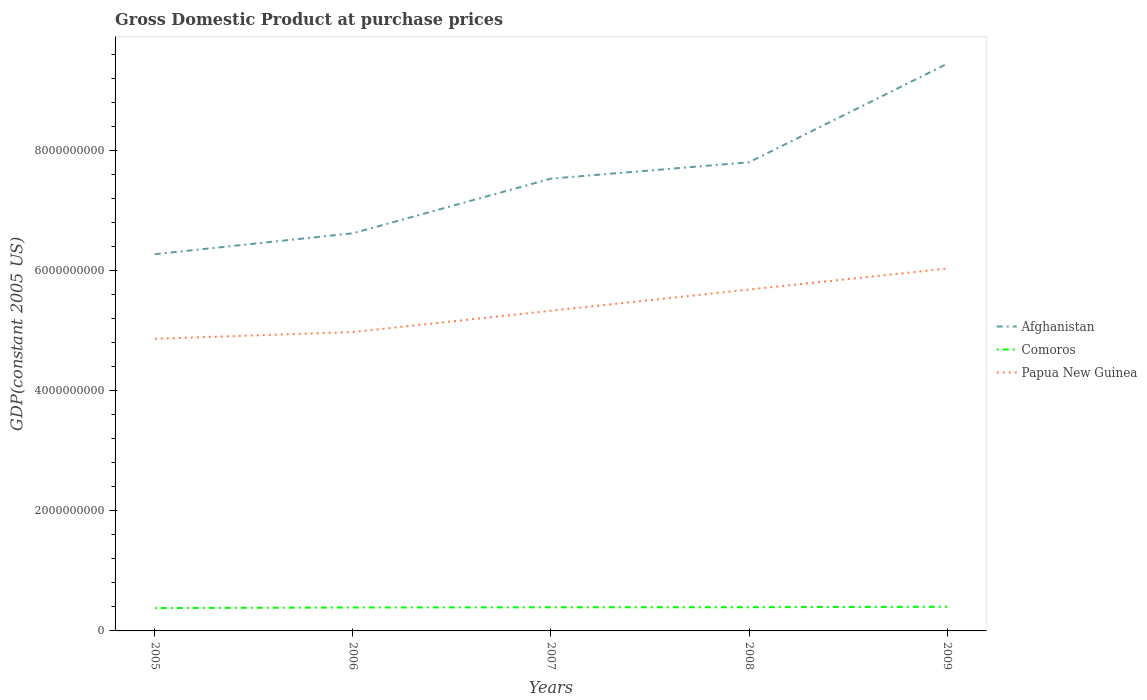Does the line corresponding to Comoros intersect with the line corresponding to Afghanistan?
Your answer should be compact. No. Across all years, what is the maximum GDP at purchase prices in Afghanistan?
Make the answer very short. 6.28e+09. In which year was the GDP at purchase prices in Papua New Guinea maximum?
Your response must be concise. 2005. What is the total GDP at purchase prices in Comoros in the graph?
Ensure brevity in your answer.  -3.12e+06. What is the difference between the highest and the second highest GDP at purchase prices in Papua New Guinea?
Your answer should be compact. 1.17e+09. Is the GDP at purchase prices in Comoros strictly greater than the GDP at purchase prices in Papua New Guinea over the years?
Your answer should be compact. Yes. How many lines are there?
Offer a terse response. 3. What is the difference between two consecutive major ticks on the Y-axis?
Ensure brevity in your answer.  2.00e+09. Does the graph contain any zero values?
Provide a succinct answer. No. What is the title of the graph?
Offer a terse response. Gross Domestic Product at purchase prices. What is the label or title of the Y-axis?
Offer a very short reply. GDP(constant 2005 US). What is the GDP(constant 2005 US) in Afghanistan in 2005?
Offer a terse response. 6.28e+09. What is the GDP(constant 2005 US) in Comoros in 2005?
Your response must be concise. 3.80e+08. What is the GDP(constant 2005 US) of Papua New Guinea in 2005?
Keep it short and to the point. 4.87e+09. What is the GDP(constant 2005 US) of Afghanistan in 2006?
Your response must be concise. 6.62e+09. What is the GDP(constant 2005 US) in Comoros in 2006?
Provide a short and direct response. 3.90e+08. What is the GDP(constant 2005 US) in Papua New Guinea in 2006?
Provide a succinct answer. 4.98e+09. What is the GDP(constant 2005 US) in Afghanistan in 2007?
Offer a very short reply. 7.53e+09. What is the GDP(constant 2005 US) in Comoros in 2007?
Provide a short and direct response. 3.94e+08. What is the GDP(constant 2005 US) of Papua New Guinea in 2007?
Offer a terse response. 5.33e+09. What is the GDP(constant 2005 US) in Afghanistan in 2008?
Keep it short and to the point. 7.81e+09. What is the GDP(constant 2005 US) in Comoros in 2008?
Your answer should be compact. 3.95e+08. What is the GDP(constant 2005 US) in Papua New Guinea in 2008?
Ensure brevity in your answer.  5.69e+09. What is the GDP(constant 2005 US) in Afghanistan in 2009?
Your response must be concise. 9.45e+09. What is the GDP(constant 2005 US) in Comoros in 2009?
Give a very brief answer. 4.03e+08. What is the GDP(constant 2005 US) of Papua New Guinea in 2009?
Keep it short and to the point. 6.04e+09. Across all years, what is the maximum GDP(constant 2005 US) of Afghanistan?
Make the answer very short. 9.45e+09. Across all years, what is the maximum GDP(constant 2005 US) in Comoros?
Your response must be concise. 4.03e+08. Across all years, what is the maximum GDP(constant 2005 US) in Papua New Guinea?
Keep it short and to the point. 6.04e+09. Across all years, what is the minimum GDP(constant 2005 US) of Afghanistan?
Your answer should be very brief. 6.28e+09. Across all years, what is the minimum GDP(constant 2005 US) of Comoros?
Provide a succinct answer. 3.80e+08. Across all years, what is the minimum GDP(constant 2005 US) of Papua New Guinea?
Offer a terse response. 4.87e+09. What is the total GDP(constant 2005 US) of Afghanistan in the graph?
Make the answer very short. 3.77e+1. What is the total GDP(constant 2005 US) of Comoros in the graph?
Make the answer very short. 1.96e+09. What is the total GDP(constant 2005 US) of Papua New Guinea in the graph?
Offer a terse response. 2.69e+1. What is the difference between the GDP(constant 2005 US) in Afghanistan in 2005 and that in 2006?
Keep it short and to the point. -3.49e+08. What is the difference between the GDP(constant 2005 US) of Comoros in 2005 and that in 2006?
Provide a short and direct response. -1.01e+07. What is the difference between the GDP(constant 2005 US) in Papua New Guinea in 2005 and that in 2006?
Offer a very short reply. -1.12e+08. What is the difference between the GDP(constant 2005 US) of Afghanistan in 2005 and that in 2007?
Make the answer very short. -1.26e+09. What is the difference between the GDP(constant 2005 US) in Comoros in 2005 and that in 2007?
Ensure brevity in your answer.  -1.32e+07. What is the difference between the GDP(constant 2005 US) in Papua New Guinea in 2005 and that in 2007?
Offer a terse response. -4.68e+08. What is the difference between the GDP(constant 2005 US) of Afghanistan in 2005 and that in 2008?
Make the answer very short. -1.53e+09. What is the difference between the GDP(constant 2005 US) of Comoros in 2005 and that in 2008?
Your answer should be very brief. -1.48e+07. What is the difference between the GDP(constant 2005 US) in Papua New Guinea in 2005 and that in 2008?
Make the answer very short. -8.20e+08. What is the difference between the GDP(constant 2005 US) of Afghanistan in 2005 and that in 2009?
Provide a short and direct response. -3.17e+09. What is the difference between the GDP(constant 2005 US) in Comoros in 2005 and that in 2009?
Ensure brevity in your answer.  -2.25e+07. What is the difference between the GDP(constant 2005 US) of Papua New Guinea in 2005 and that in 2009?
Your answer should be compact. -1.17e+09. What is the difference between the GDP(constant 2005 US) of Afghanistan in 2006 and that in 2007?
Ensure brevity in your answer.  -9.10e+08. What is the difference between the GDP(constant 2005 US) in Comoros in 2006 and that in 2007?
Provide a short and direct response. -3.12e+06. What is the difference between the GDP(constant 2005 US) in Papua New Guinea in 2006 and that in 2007?
Provide a succinct answer. -3.56e+08. What is the difference between the GDP(constant 2005 US) in Afghanistan in 2006 and that in 2008?
Provide a short and direct response. -1.18e+09. What is the difference between the GDP(constant 2005 US) in Comoros in 2006 and that in 2008?
Provide a short and direct response. -4.70e+06. What is the difference between the GDP(constant 2005 US) of Papua New Guinea in 2006 and that in 2008?
Offer a terse response. -7.09e+08. What is the difference between the GDP(constant 2005 US) of Afghanistan in 2006 and that in 2009?
Ensure brevity in your answer.  -2.82e+09. What is the difference between the GDP(constant 2005 US) of Comoros in 2006 and that in 2009?
Keep it short and to the point. -1.24e+07. What is the difference between the GDP(constant 2005 US) of Papua New Guinea in 2006 and that in 2009?
Provide a short and direct response. -1.06e+09. What is the difference between the GDP(constant 2005 US) in Afghanistan in 2007 and that in 2008?
Make the answer very short. -2.72e+08. What is the difference between the GDP(constant 2005 US) of Comoros in 2007 and that in 2008?
Your answer should be compact. -1.58e+06. What is the difference between the GDP(constant 2005 US) of Papua New Guinea in 2007 and that in 2008?
Make the answer very short. -3.53e+08. What is the difference between the GDP(constant 2005 US) in Afghanistan in 2007 and that in 2009?
Your answer should be very brief. -1.91e+09. What is the difference between the GDP(constant 2005 US) of Comoros in 2007 and that in 2009?
Your response must be concise. -9.28e+06. What is the difference between the GDP(constant 2005 US) in Papua New Guinea in 2007 and that in 2009?
Make the answer very short. -7.02e+08. What is the difference between the GDP(constant 2005 US) in Afghanistan in 2008 and that in 2009?
Your answer should be compact. -1.64e+09. What is the difference between the GDP(constant 2005 US) in Comoros in 2008 and that in 2009?
Your answer should be very brief. -7.71e+06. What is the difference between the GDP(constant 2005 US) of Papua New Guinea in 2008 and that in 2009?
Provide a succinct answer. -3.49e+08. What is the difference between the GDP(constant 2005 US) of Afghanistan in 2005 and the GDP(constant 2005 US) of Comoros in 2006?
Offer a very short reply. 5.88e+09. What is the difference between the GDP(constant 2005 US) in Afghanistan in 2005 and the GDP(constant 2005 US) in Papua New Guinea in 2006?
Give a very brief answer. 1.30e+09. What is the difference between the GDP(constant 2005 US) in Comoros in 2005 and the GDP(constant 2005 US) in Papua New Guinea in 2006?
Your answer should be compact. -4.60e+09. What is the difference between the GDP(constant 2005 US) of Afghanistan in 2005 and the GDP(constant 2005 US) of Comoros in 2007?
Offer a terse response. 5.88e+09. What is the difference between the GDP(constant 2005 US) of Afghanistan in 2005 and the GDP(constant 2005 US) of Papua New Guinea in 2007?
Ensure brevity in your answer.  9.41e+08. What is the difference between the GDP(constant 2005 US) of Comoros in 2005 and the GDP(constant 2005 US) of Papua New Guinea in 2007?
Your answer should be compact. -4.95e+09. What is the difference between the GDP(constant 2005 US) of Afghanistan in 2005 and the GDP(constant 2005 US) of Comoros in 2008?
Offer a very short reply. 5.88e+09. What is the difference between the GDP(constant 2005 US) of Afghanistan in 2005 and the GDP(constant 2005 US) of Papua New Guinea in 2008?
Keep it short and to the point. 5.89e+08. What is the difference between the GDP(constant 2005 US) in Comoros in 2005 and the GDP(constant 2005 US) in Papua New Guinea in 2008?
Give a very brief answer. -5.31e+09. What is the difference between the GDP(constant 2005 US) of Afghanistan in 2005 and the GDP(constant 2005 US) of Comoros in 2009?
Make the answer very short. 5.87e+09. What is the difference between the GDP(constant 2005 US) of Afghanistan in 2005 and the GDP(constant 2005 US) of Papua New Guinea in 2009?
Make the answer very short. 2.40e+08. What is the difference between the GDP(constant 2005 US) of Comoros in 2005 and the GDP(constant 2005 US) of Papua New Guinea in 2009?
Your response must be concise. -5.66e+09. What is the difference between the GDP(constant 2005 US) in Afghanistan in 2006 and the GDP(constant 2005 US) in Comoros in 2007?
Ensure brevity in your answer.  6.23e+09. What is the difference between the GDP(constant 2005 US) in Afghanistan in 2006 and the GDP(constant 2005 US) in Papua New Guinea in 2007?
Make the answer very short. 1.29e+09. What is the difference between the GDP(constant 2005 US) of Comoros in 2006 and the GDP(constant 2005 US) of Papua New Guinea in 2007?
Ensure brevity in your answer.  -4.94e+09. What is the difference between the GDP(constant 2005 US) in Afghanistan in 2006 and the GDP(constant 2005 US) in Comoros in 2008?
Keep it short and to the point. 6.23e+09. What is the difference between the GDP(constant 2005 US) of Afghanistan in 2006 and the GDP(constant 2005 US) of Papua New Guinea in 2008?
Offer a very short reply. 9.37e+08. What is the difference between the GDP(constant 2005 US) in Comoros in 2006 and the GDP(constant 2005 US) in Papua New Guinea in 2008?
Offer a very short reply. -5.30e+09. What is the difference between the GDP(constant 2005 US) in Afghanistan in 2006 and the GDP(constant 2005 US) in Comoros in 2009?
Keep it short and to the point. 6.22e+09. What is the difference between the GDP(constant 2005 US) in Afghanistan in 2006 and the GDP(constant 2005 US) in Papua New Guinea in 2009?
Your answer should be very brief. 5.88e+08. What is the difference between the GDP(constant 2005 US) in Comoros in 2006 and the GDP(constant 2005 US) in Papua New Guinea in 2009?
Offer a very short reply. -5.64e+09. What is the difference between the GDP(constant 2005 US) of Afghanistan in 2007 and the GDP(constant 2005 US) of Comoros in 2008?
Provide a succinct answer. 7.14e+09. What is the difference between the GDP(constant 2005 US) of Afghanistan in 2007 and the GDP(constant 2005 US) of Papua New Guinea in 2008?
Your answer should be compact. 1.85e+09. What is the difference between the GDP(constant 2005 US) in Comoros in 2007 and the GDP(constant 2005 US) in Papua New Guinea in 2008?
Ensure brevity in your answer.  -5.29e+09. What is the difference between the GDP(constant 2005 US) of Afghanistan in 2007 and the GDP(constant 2005 US) of Comoros in 2009?
Ensure brevity in your answer.  7.13e+09. What is the difference between the GDP(constant 2005 US) of Afghanistan in 2007 and the GDP(constant 2005 US) of Papua New Guinea in 2009?
Make the answer very short. 1.50e+09. What is the difference between the GDP(constant 2005 US) of Comoros in 2007 and the GDP(constant 2005 US) of Papua New Guinea in 2009?
Provide a short and direct response. -5.64e+09. What is the difference between the GDP(constant 2005 US) in Afghanistan in 2008 and the GDP(constant 2005 US) in Comoros in 2009?
Offer a terse response. 7.40e+09. What is the difference between the GDP(constant 2005 US) in Afghanistan in 2008 and the GDP(constant 2005 US) in Papua New Guinea in 2009?
Keep it short and to the point. 1.77e+09. What is the difference between the GDP(constant 2005 US) in Comoros in 2008 and the GDP(constant 2005 US) in Papua New Guinea in 2009?
Offer a terse response. -5.64e+09. What is the average GDP(constant 2005 US) of Afghanistan per year?
Give a very brief answer. 7.54e+09. What is the average GDP(constant 2005 US) in Comoros per year?
Make the answer very short. 3.92e+08. What is the average GDP(constant 2005 US) of Papua New Guinea per year?
Make the answer very short. 5.38e+09. In the year 2005, what is the difference between the GDP(constant 2005 US) in Afghanistan and GDP(constant 2005 US) in Comoros?
Your answer should be compact. 5.89e+09. In the year 2005, what is the difference between the GDP(constant 2005 US) in Afghanistan and GDP(constant 2005 US) in Papua New Guinea?
Provide a succinct answer. 1.41e+09. In the year 2005, what is the difference between the GDP(constant 2005 US) of Comoros and GDP(constant 2005 US) of Papua New Guinea?
Provide a succinct answer. -4.49e+09. In the year 2006, what is the difference between the GDP(constant 2005 US) of Afghanistan and GDP(constant 2005 US) of Comoros?
Make the answer very short. 6.23e+09. In the year 2006, what is the difference between the GDP(constant 2005 US) of Afghanistan and GDP(constant 2005 US) of Papua New Guinea?
Provide a succinct answer. 1.65e+09. In the year 2006, what is the difference between the GDP(constant 2005 US) in Comoros and GDP(constant 2005 US) in Papua New Guinea?
Your answer should be compact. -4.59e+09. In the year 2007, what is the difference between the GDP(constant 2005 US) of Afghanistan and GDP(constant 2005 US) of Comoros?
Make the answer very short. 7.14e+09. In the year 2007, what is the difference between the GDP(constant 2005 US) in Afghanistan and GDP(constant 2005 US) in Papua New Guinea?
Give a very brief answer. 2.20e+09. In the year 2007, what is the difference between the GDP(constant 2005 US) of Comoros and GDP(constant 2005 US) of Papua New Guinea?
Provide a short and direct response. -4.94e+09. In the year 2008, what is the difference between the GDP(constant 2005 US) in Afghanistan and GDP(constant 2005 US) in Comoros?
Provide a succinct answer. 7.41e+09. In the year 2008, what is the difference between the GDP(constant 2005 US) of Afghanistan and GDP(constant 2005 US) of Papua New Guinea?
Your response must be concise. 2.12e+09. In the year 2008, what is the difference between the GDP(constant 2005 US) of Comoros and GDP(constant 2005 US) of Papua New Guinea?
Give a very brief answer. -5.29e+09. In the year 2009, what is the difference between the GDP(constant 2005 US) of Afghanistan and GDP(constant 2005 US) of Comoros?
Offer a terse response. 9.04e+09. In the year 2009, what is the difference between the GDP(constant 2005 US) in Afghanistan and GDP(constant 2005 US) in Papua New Guinea?
Provide a short and direct response. 3.41e+09. In the year 2009, what is the difference between the GDP(constant 2005 US) in Comoros and GDP(constant 2005 US) in Papua New Guinea?
Offer a very short reply. -5.63e+09. What is the ratio of the GDP(constant 2005 US) of Comoros in 2005 to that in 2006?
Your answer should be compact. 0.97. What is the ratio of the GDP(constant 2005 US) of Papua New Guinea in 2005 to that in 2006?
Your answer should be compact. 0.98. What is the ratio of the GDP(constant 2005 US) of Afghanistan in 2005 to that in 2007?
Keep it short and to the point. 0.83. What is the ratio of the GDP(constant 2005 US) of Comoros in 2005 to that in 2007?
Keep it short and to the point. 0.97. What is the ratio of the GDP(constant 2005 US) in Papua New Guinea in 2005 to that in 2007?
Offer a terse response. 0.91. What is the ratio of the GDP(constant 2005 US) in Afghanistan in 2005 to that in 2008?
Give a very brief answer. 0.8. What is the ratio of the GDP(constant 2005 US) in Comoros in 2005 to that in 2008?
Ensure brevity in your answer.  0.96. What is the ratio of the GDP(constant 2005 US) of Papua New Guinea in 2005 to that in 2008?
Make the answer very short. 0.86. What is the ratio of the GDP(constant 2005 US) in Afghanistan in 2005 to that in 2009?
Keep it short and to the point. 0.66. What is the ratio of the GDP(constant 2005 US) in Comoros in 2005 to that in 2009?
Ensure brevity in your answer.  0.94. What is the ratio of the GDP(constant 2005 US) of Papua New Guinea in 2005 to that in 2009?
Your answer should be very brief. 0.81. What is the ratio of the GDP(constant 2005 US) in Afghanistan in 2006 to that in 2007?
Give a very brief answer. 0.88. What is the ratio of the GDP(constant 2005 US) in Comoros in 2006 to that in 2007?
Offer a terse response. 0.99. What is the ratio of the GDP(constant 2005 US) of Papua New Guinea in 2006 to that in 2007?
Provide a short and direct response. 0.93. What is the ratio of the GDP(constant 2005 US) of Afghanistan in 2006 to that in 2008?
Offer a terse response. 0.85. What is the ratio of the GDP(constant 2005 US) of Comoros in 2006 to that in 2008?
Offer a terse response. 0.99. What is the ratio of the GDP(constant 2005 US) of Papua New Guinea in 2006 to that in 2008?
Your answer should be very brief. 0.88. What is the ratio of the GDP(constant 2005 US) in Afghanistan in 2006 to that in 2009?
Provide a succinct answer. 0.7. What is the ratio of the GDP(constant 2005 US) in Comoros in 2006 to that in 2009?
Make the answer very short. 0.97. What is the ratio of the GDP(constant 2005 US) in Papua New Guinea in 2006 to that in 2009?
Your answer should be compact. 0.82. What is the ratio of the GDP(constant 2005 US) of Afghanistan in 2007 to that in 2008?
Your answer should be compact. 0.97. What is the ratio of the GDP(constant 2005 US) of Comoros in 2007 to that in 2008?
Offer a very short reply. 1. What is the ratio of the GDP(constant 2005 US) in Papua New Guinea in 2007 to that in 2008?
Offer a very short reply. 0.94. What is the ratio of the GDP(constant 2005 US) in Afghanistan in 2007 to that in 2009?
Ensure brevity in your answer.  0.8. What is the ratio of the GDP(constant 2005 US) in Papua New Guinea in 2007 to that in 2009?
Ensure brevity in your answer.  0.88. What is the ratio of the GDP(constant 2005 US) in Afghanistan in 2008 to that in 2009?
Offer a terse response. 0.83. What is the ratio of the GDP(constant 2005 US) in Comoros in 2008 to that in 2009?
Give a very brief answer. 0.98. What is the ratio of the GDP(constant 2005 US) in Papua New Guinea in 2008 to that in 2009?
Give a very brief answer. 0.94. What is the difference between the highest and the second highest GDP(constant 2005 US) of Afghanistan?
Keep it short and to the point. 1.64e+09. What is the difference between the highest and the second highest GDP(constant 2005 US) of Comoros?
Keep it short and to the point. 7.71e+06. What is the difference between the highest and the second highest GDP(constant 2005 US) in Papua New Guinea?
Provide a succinct answer. 3.49e+08. What is the difference between the highest and the lowest GDP(constant 2005 US) in Afghanistan?
Give a very brief answer. 3.17e+09. What is the difference between the highest and the lowest GDP(constant 2005 US) of Comoros?
Ensure brevity in your answer.  2.25e+07. What is the difference between the highest and the lowest GDP(constant 2005 US) of Papua New Guinea?
Provide a succinct answer. 1.17e+09. 